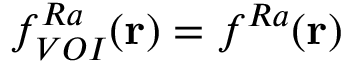<formula> <loc_0><loc_0><loc_500><loc_500>f _ { V O I } ^ { R a } ( r ) = f ^ { R a } ( r )</formula> 